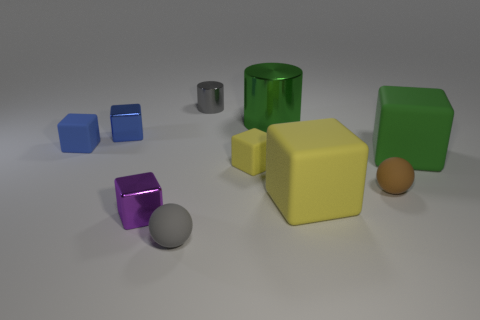Subtract all small rubber blocks. How many blocks are left? 4 Subtract all yellow blocks. How many blocks are left? 4 Subtract all brown cubes. Subtract all brown cylinders. How many cubes are left? 6 Subtract all spheres. How many objects are left? 8 Add 9 big purple matte cylinders. How many big purple matte cylinders exist? 9 Subtract 0 yellow spheres. How many objects are left? 10 Subtract all big blue shiny blocks. Subtract all brown objects. How many objects are left? 9 Add 3 small yellow cubes. How many small yellow cubes are left? 4 